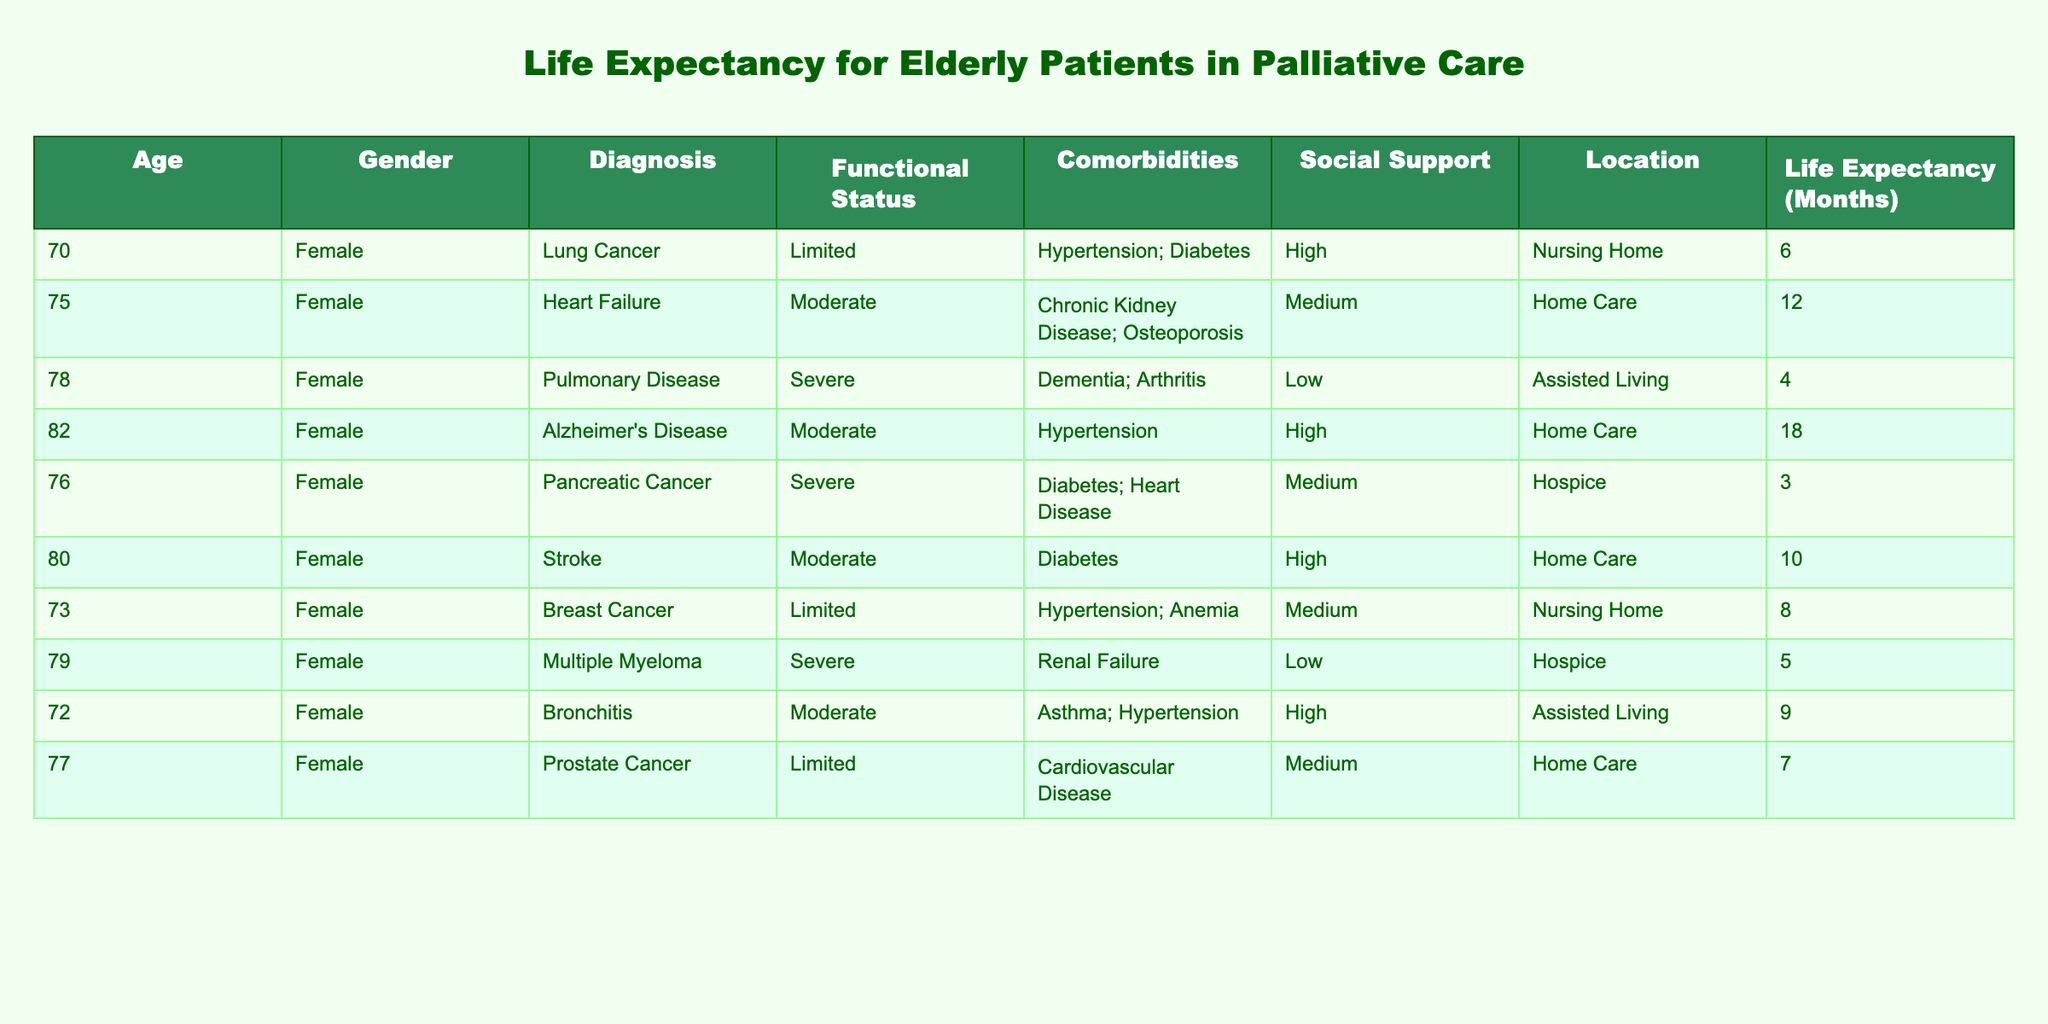What is the life expectancy of a 79-year-old female with Multiple Myeloma? The table lists the life expectancy for a 79-year-old female patient with Multiple Myeloma as 5 months.
Answer: 5 months Which patient has the highest social support and what is her life expectancy? Looking through the table, the highest social support is "High" for the 82-year-old female with Alzheimer's Disease, whose life expectancy is 18 months.
Answer: 18 months What is the average life expectancy of patients with a severe functional status? The patients with severe functional status are the 78-year-old with Pulmonary Disease (4 months), 76-year-old with Pancreatic Cancer (3 months), and 79-year-old with Multiple Myeloma (5 months). The sum is 4 + 3 + 5 = 12 months. There are 3 patients, so the average is 12/3 = 4 months.
Answer: 4 months Is there any patient receiving hospice care who has a life expectancy of more than 6 months? The table shows two patients in hospice care. One is the 76-year-old with a life expectancy of 3 months, and the other is the 79-year-old with a life expectancy of 5 months. Therefore, there are no hospice patients with life expectancy over 6 months.
Answer: No How many patients have a diagnosis of cancer and what is their combined life expectancy? The patients with cancer diagnoses are the 70-year-old with Lung Cancer (6 months), 75-year-old with Heart Failure (12 months), 73-year-old with Breast Cancer (8 months), 76-year-old with Pancreatic Cancer (3 months), and 79-year-old with Multiple Myeloma (5 months). Their combined life expectancy is 6 + 12 + 8 + 3 + 5 = 34 months, and there are 5 patients.
Answer: 34 months 